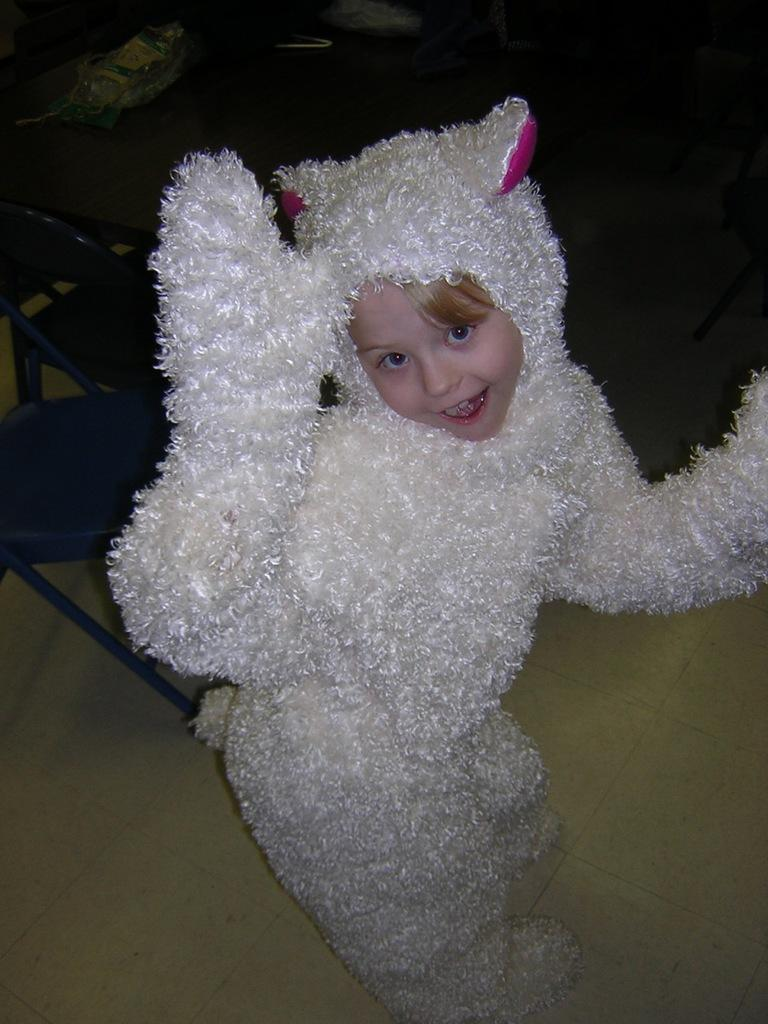Who is the main subject in the image? There is a girl wearing a costume in the center of the image. What can be seen in the background of the image? There are chairs in the background of the image. What is visible at the bottom of the image? There is a floor visible at the bottom of the image. How many minutes does the girl spend in the image? The concept of time, such as minutes, is not mentioned or depicted in the image. The girl's presence in the image is a static representation and does not convey any information about the duration of her presence. 